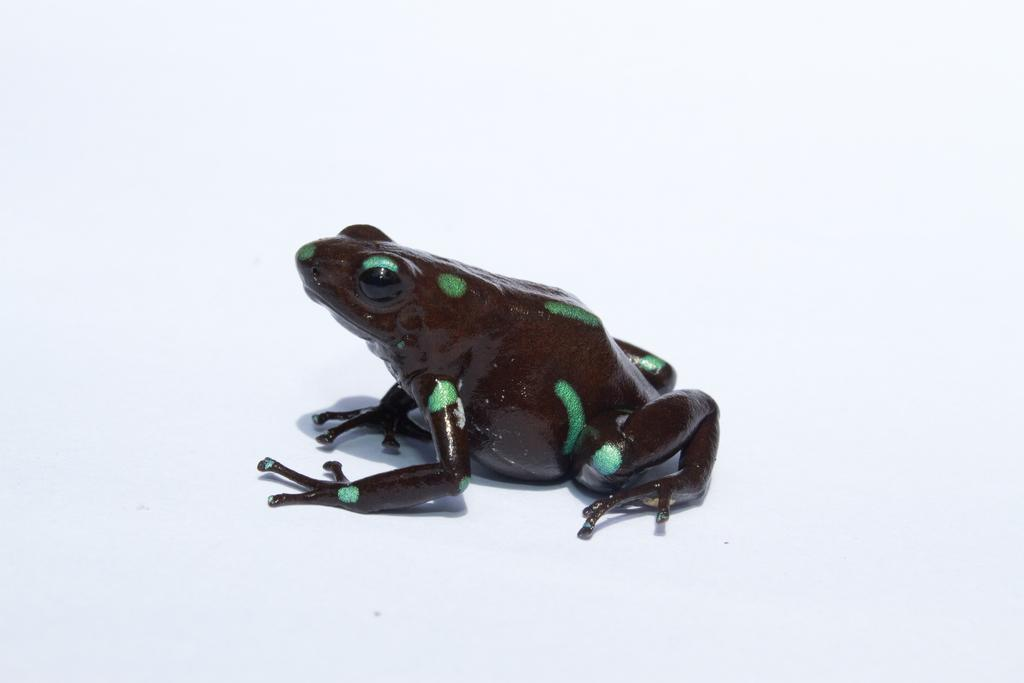What animal is the main subject of the picture? There is a frog in the picture. What colors can be seen on the frog? The frog has a green and black color. Where is the frog located in the image? The frog is in the front of the image. What is the color of the background in the image? There is a white background in the image. What type of bells can be heard ringing in the image? There are no bells present in the image, and therefore no sound can be heard. What subject is being taught in the school depicted in the image? There is no school depicted in the image; it features a frog on a white background. 